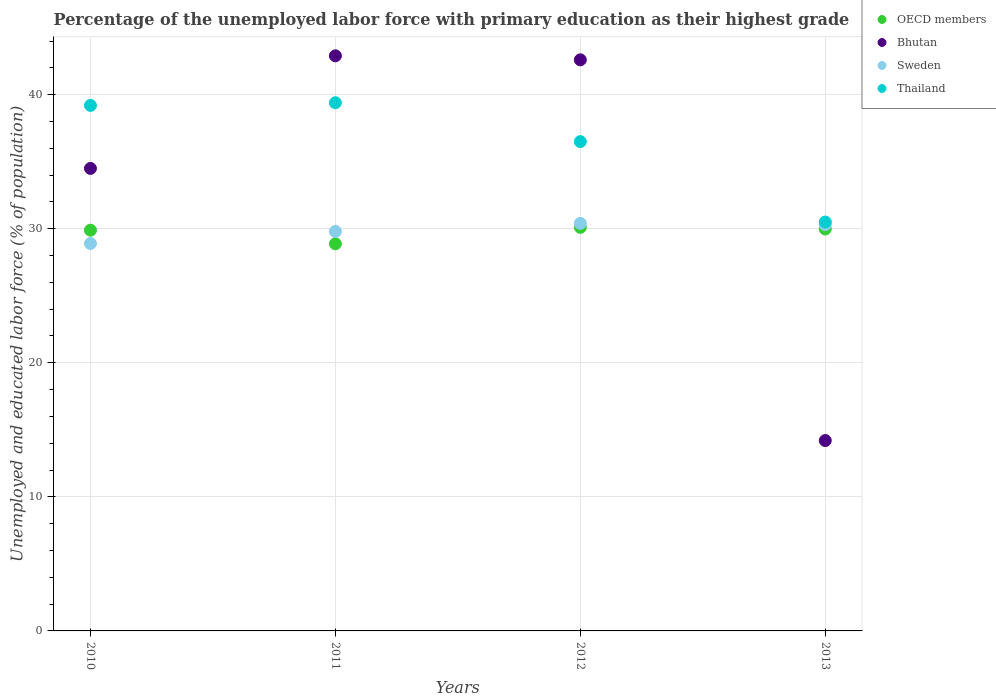How many different coloured dotlines are there?
Keep it short and to the point. 4. What is the percentage of the unemployed labor force with primary education in Bhutan in 2012?
Provide a succinct answer. 42.6. Across all years, what is the maximum percentage of the unemployed labor force with primary education in Bhutan?
Offer a terse response. 42.9. Across all years, what is the minimum percentage of the unemployed labor force with primary education in OECD members?
Offer a very short reply. 28.88. In which year was the percentage of the unemployed labor force with primary education in Bhutan maximum?
Make the answer very short. 2011. In which year was the percentage of the unemployed labor force with primary education in Thailand minimum?
Offer a very short reply. 2013. What is the total percentage of the unemployed labor force with primary education in OECD members in the graph?
Keep it short and to the point. 118.86. What is the difference between the percentage of the unemployed labor force with primary education in Thailand in 2011 and that in 2012?
Provide a succinct answer. 2.9. What is the difference between the percentage of the unemployed labor force with primary education in Thailand in 2011 and the percentage of the unemployed labor force with primary education in Bhutan in 2013?
Your response must be concise. 25.2. What is the average percentage of the unemployed labor force with primary education in Thailand per year?
Your answer should be compact. 36.4. In the year 2010, what is the difference between the percentage of the unemployed labor force with primary education in Thailand and percentage of the unemployed labor force with primary education in Sweden?
Give a very brief answer. 10.3. In how many years, is the percentage of the unemployed labor force with primary education in Thailand greater than 12 %?
Offer a terse response. 4. What is the ratio of the percentage of the unemployed labor force with primary education in OECD members in 2010 to that in 2012?
Your answer should be very brief. 0.99. Is the percentage of the unemployed labor force with primary education in Sweden in 2011 less than that in 2012?
Give a very brief answer. Yes. What is the difference between the highest and the second highest percentage of the unemployed labor force with primary education in OECD members?
Your response must be concise. 0.12. What is the difference between the highest and the lowest percentage of the unemployed labor force with primary education in Sweden?
Give a very brief answer. 1.5. Is the sum of the percentage of the unemployed labor force with primary education in Thailand in 2011 and 2013 greater than the maximum percentage of the unemployed labor force with primary education in OECD members across all years?
Your response must be concise. Yes. Is it the case that in every year, the sum of the percentage of the unemployed labor force with primary education in OECD members and percentage of the unemployed labor force with primary education in Bhutan  is greater than the sum of percentage of the unemployed labor force with primary education in Sweden and percentage of the unemployed labor force with primary education in Thailand?
Your answer should be compact. No. Is it the case that in every year, the sum of the percentage of the unemployed labor force with primary education in OECD members and percentage of the unemployed labor force with primary education in Thailand  is greater than the percentage of the unemployed labor force with primary education in Sweden?
Offer a very short reply. Yes. Is the percentage of the unemployed labor force with primary education in OECD members strictly greater than the percentage of the unemployed labor force with primary education in Bhutan over the years?
Give a very brief answer. No. How many dotlines are there?
Provide a short and direct response. 4. How many years are there in the graph?
Your answer should be compact. 4. What is the difference between two consecutive major ticks on the Y-axis?
Provide a short and direct response. 10. Does the graph contain grids?
Make the answer very short. Yes. Where does the legend appear in the graph?
Offer a terse response. Top right. How are the legend labels stacked?
Make the answer very short. Vertical. What is the title of the graph?
Keep it short and to the point. Percentage of the unemployed labor force with primary education as their highest grade. What is the label or title of the X-axis?
Provide a succinct answer. Years. What is the label or title of the Y-axis?
Offer a terse response. Unemployed and educated labor force (% of population). What is the Unemployed and educated labor force (% of population) of OECD members in 2010?
Provide a succinct answer. 29.89. What is the Unemployed and educated labor force (% of population) of Bhutan in 2010?
Offer a terse response. 34.5. What is the Unemployed and educated labor force (% of population) in Sweden in 2010?
Your answer should be compact. 28.9. What is the Unemployed and educated labor force (% of population) of Thailand in 2010?
Offer a very short reply. 39.2. What is the Unemployed and educated labor force (% of population) of OECD members in 2011?
Your answer should be very brief. 28.88. What is the Unemployed and educated labor force (% of population) in Bhutan in 2011?
Your answer should be very brief. 42.9. What is the Unemployed and educated labor force (% of population) in Sweden in 2011?
Ensure brevity in your answer.  29.8. What is the Unemployed and educated labor force (% of population) of Thailand in 2011?
Provide a short and direct response. 39.4. What is the Unemployed and educated labor force (% of population) in OECD members in 2012?
Your answer should be very brief. 30.1. What is the Unemployed and educated labor force (% of population) in Bhutan in 2012?
Your response must be concise. 42.6. What is the Unemployed and educated labor force (% of population) of Sweden in 2012?
Provide a succinct answer. 30.4. What is the Unemployed and educated labor force (% of population) of Thailand in 2012?
Offer a very short reply. 36.5. What is the Unemployed and educated labor force (% of population) in OECD members in 2013?
Provide a short and direct response. 29.98. What is the Unemployed and educated labor force (% of population) in Bhutan in 2013?
Provide a succinct answer. 14.2. What is the Unemployed and educated labor force (% of population) in Sweden in 2013?
Your response must be concise. 30.3. What is the Unemployed and educated labor force (% of population) in Thailand in 2013?
Make the answer very short. 30.5. Across all years, what is the maximum Unemployed and educated labor force (% of population) of OECD members?
Keep it short and to the point. 30.1. Across all years, what is the maximum Unemployed and educated labor force (% of population) in Bhutan?
Give a very brief answer. 42.9. Across all years, what is the maximum Unemployed and educated labor force (% of population) of Sweden?
Give a very brief answer. 30.4. Across all years, what is the maximum Unemployed and educated labor force (% of population) in Thailand?
Your response must be concise. 39.4. Across all years, what is the minimum Unemployed and educated labor force (% of population) in OECD members?
Your answer should be compact. 28.88. Across all years, what is the minimum Unemployed and educated labor force (% of population) in Bhutan?
Provide a succinct answer. 14.2. Across all years, what is the minimum Unemployed and educated labor force (% of population) in Sweden?
Provide a short and direct response. 28.9. Across all years, what is the minimum Unemployed and educated labor force (% of population) of Thailand?
Your answer should be very brief. 30.5. What is the total Unemployed and educated labor force (% of population) of OECD members in the graph?
Your response must be concise. 118.86. What is the total Unemployed and educated labor force (% of population) of Bhutan in the graph?
Provide a succinct answer. 134.2. What is the total Unemployed and educated labor force (% of population) of Sweden in the graph?
Offer a very short reply. 119.4. What is the total Unemployed and educated labor force (% of population) in Thailand in the graph?
Offer a very short reply. 145.6. What is the difference between the Unemployed and educated labor force (% of population) in OECD members in 2010 and that in 2011?
Offer a very short reply. 1.01. What is the difference between the Unemployed and educated labor force (% of population) in Sweden in 2010 and that in 2011?
Provide a short and direct response. -0.9. What is the difference between the Unemployed and educated labor force (% of population) in OECD members in 2010 and that in 2012?
Give a very brief answer. -0.21. What is the difference between the Unemployed and educated labor force (% of population) of Bhutan in 2010 and that in 2012?
Your response must be concise. -8.1. What is the difference between the Unemployed and educated labor force (% of population) of Thailand in 2010 and that in 2012?
Offer a terse response. 2.7. What is the difference between the Unemployed and educated labor force (% of population) in OECD members in 2010 and that in 2013?
Keep it short and to the point. -0.09. What is the difference between the Unemployed and educated labor force (% of population) of Bhutan in 2010 and that in 2013?
Your answer should be very brief. 20.3. What is the difference between the Unemployed and educated labor force (% of population) of Thailand in 2010 and that in 2013?
Provide a succinct answer. 8.7. What is the difference between the Unemployed and educated labor force (% of population) of OECD members in 2011 and that in 2012?
Your answer should be compact. -1.23. What is the difference between the Unemployed and educated labor force (% of population) of Sweden in 2011 and that in 2012?
Ensure brevity in your answer.  -0.6. What is the difference between the Unemployed and educated labor force (% of population) of OECD members in 2011 and that in 2013?
Ensure brevity in your answer.  -1.11. What is the difference between the Unemployed and educated labor force (% of population) of Bhutan in 2011 and that in 2013?
Keep it short and to the point. 28.7. What is the difference between the Unemployed and educated labor force (% of population) of Sweden in 2011 and that in 2013?
Make the answer very short. -0.5. What is the difference between the Unemployed and educated labor force (% of population) of Thailand in 2011 and that in 2013?
Make the answer very short. 8.9. What is the difference between the Unemployed and educated labor force (% of population) of OECD members in 2012 and that in 2013?
Your answer should be very brief. 0.12. What is the difference between the Unemployed and educated labor force (% of population) in Bhutan in 2012 and that in 2013?
Your answer should be very brief. 28.4. What is the difference between the Unemployed and educated labor force (% of population) of OECD members in 2010 and the Unemployed and educated labor force (% of population) of Bhutan in 2011?
Keep it short and to the point. -13.01. What is the difference between the Unemployed and educated labor force (% of population) in OECD members in 2010 and the Unemployed and educated labor force (% of population) in Sweden in 2011?
Offer a terse response. 0.09. What is the difference between the Unemployed and educated labor force (% of population) of OECD members in 2010 and the Unemployed and educated labor force (% of population) of Thailand in 2011?
Give a very brief answer. -9.51. What is the difference between the Unemployed and educated labor force (% of population) of OECD members in 2010 and the Unemployed and educated labor force (% of population) of Bhutan in 2012?
Your response must be concise. -12.71. What is the difference between the Unemployed and educated labor force (% of population) in OECD members in 2010 and the Unemployed and educated labor force (% of population) in Sweden in 2012?
Make the answer very short. -0.51. What is the difference between the Unemployed and educated labor force (% of population) of OECD members in 2010 and the Unemployed and educated labor force (% of population) of Thailand in 2012?
Ensure brevity in your answer.  -6.61. What is the difference between the Unemployed and educated labor force (% of population) of Bhutan in 2010 and the Unemployed and educated labor force (% of population) of Thailand in 2012?
Give a very brief answer. -2. What is the difference between the Unemployed and educated labor force (% of population) in Sweden in 2010 and the Unemployed and educated labor force (% of population) in Thailand in 2012?
Provide a short and direct response. -7.6. What is the difference between the Unemployed and educated labor force (% of population) in OECD members in 2010 and the Unemployed and educated labor force (% of population) in Bhutan in 2013?
Ensure brevity in your answer.  15.69. What is the difference between the Unemployed and educated labor force (% of population) in OECD members in 2010 and the Unemployed and educated labor force (% of population) in Sweden in 2013?
Offer a terse response. -0.41. What is the difference between the Unemployed and educated labor force (% of population) of OECD members in 2010 and the Unemployed and educated labor force (% of population) of Thailand in 2013?
Provide a succinct answer. -0.61. What is the difference between the Unemployed and educated labor force (% of population) in Bhutan in 2010 and the Unemployed and educated labor force (% of population) in Sweden in 2013?
Offer a terse response. 4.2. What is the difference between the Unemployed and educated labor force (% of population) in Sweden in 2010 and the Unemployed and educated labor force (% of population) in Thailand in 2013?
Ensure brevity in your answer.  -1.6. What is the difference between the Unemployed and educated labor force (% of population) in OECD members in 2011 and the Unemployed and educated labor force (% of population) in Bhutan in 2012?
Provide a succinct answer. -13.72. What is the difference between the Unemployed and educated labor force (% of population) of OECD members in 2011 and the Unemployed and educated labor force (% of population) of Sweden in 2012?
Keep it short and to the point. -1.52. What is the difference between the Unemployed and educated labor force (% of population) in OECD members in 2011 and the Unemployed and educated labor force (% of population) in Thailand in 2012?
Your answer should be compact. -7.62. What is the difference between the Unemployed and educated labor force (% of population) of Sweden in 2011 and the Unemployed and educated labor force (% of population) of Thailand in 2012?
Provide a short and direct response. -6.7. What is the difference between the Unemployed and educated labor force (% of population) of OECD members in 2011 and the Unemployed and educated labor force (% of population) of Bhutan in 2013?
Provide a short and direct response. 14.68. What is the difference between the Unemployed and educated labor force (% of population) of OECD members in 2011 and the Unemployed and educated labor force (% of population) of Sweden in 2013?
Provide a short and direct response. -1.42. What is the difference between the Unemployed and educated labor force (% of population) of OECD members in 2011 and the Unemployed and educated labor force (% of population) of Thailand in 2013?
Give a very brief answer. -1.62. What is the difference between the Unemployed and educated labor force (% of population) in Bhutan in 2011 and the Unemployed and educated labor force (% of population) in Thailand in 2013?
Keep it short and to the point. 12.4. What is the difference between the Unemployed and educated labor force (% of population) in Sweden in 2011 and the Unemployed and educated labor force (% of population) in Thailand in 2013?
Make the answer very short. -0.7. What is the difference between the Unemployed and educated labor force (% of population) of OECD members in 2012 and the Unemployed and educated labor force (% of population) of Bhutan in 2013?
Make the answer very short. 15.9. What is the difference between the Unemployed and educated labor force (% of population) in OECD members in 2012 and the Unemployed and educated labor force (% of population) in Sweden in 2013?
Ensure brevity in your answer.  -0.2. What is the difference between the Unemployed and educated labor force (% of population) of OECD members in 2012 and the Unemployed and educated labor force (% of population) of Thailand in 2013?
Your answer should be very brief. -0.4. What is the average Unemployed and educated labor force (% of population) in OECD members per year?
Keep it short and to the point. 29.71. What is the average Unemployed and educated labor force (% of population) in Bhutan per year?
Your answer should be very brief. 33.55. What is the average Unemployed and educated labor force (% of population) of Sweden per year?
Provide a succinct answer. 29.85. What is the average Unemployed and educated labor force (% of population) of Thailand per year?
Ensure brevity in your answer.  36.4. In the year 2010, what is the difference between the Unemployed and educated labor force (% of population) of OECD members and Unemployed and educated labor force (% of population) of Bhutan?
Give a very brief answer. -4.61. In the year 2010, what is the difference between the Unemployed and educated labor force (% of population) of OECD members and Unemployed and educated labor force (% of population) of Sweden?
Your answer should be very brief. 0.99. In the year 2010, what is the difference between the Unemployed and educated labor force (% of population) of OECD members and Unemployed and educated labor force (% of population) of Thailand?
Your answer should be very brief. -9.31. In the year 2011, what is the difference between the Unemployed and educated labor force (% of population) of OECD members and Unemployed and educated labor force (% of population) of Bhutan?
Offer a very short reply. -14.02. In the year 2011, what is the difference between the Unemployed and educated labor force (% of population) of OECD members and Unemployed and educated labor force (% of population) of Sweden?
Provide a succinct answer. -0.92. In the year 2011, what is the difference between the Unemployed and educated labor force (% of population) of OECD members and Unemployed and educated labor force (% of population) of Thailand?
Make the answer very short. -10.52. In the year 2011, what is the difference between the Unemployed and educated labor force (% of population) in Bhutan and Unemployed and educated labor force (% of population) in Sweden?
Provide a short and direct response. 13.1. In the year 2012, what is the difference between the Unemployed and educated labor force (% of population) in OECD members and Unemployed and educated labor force (% of population) in Bhutan?
Ensure brevity in your answer.  -12.5. In the year 2012, what is the difference between the Unemployed and educated labor force (% of population) in OECD members and Unemployed and educated labor force (% of population) in Sweden?
Offer a very short reply. -0.3. In the year 2012, what is the difference between the Unemployed and educated labor force (% of population) in OECD members and Unemployed and educated labor force (% of population) in Thailand?
Ensure brevity in your answer.  -6.4. In the year 2012, what is the difference between the Unemployed and educated labor force (% of population) of Bhutan and Unemployed and educated labor force (% of population) of Sweden?
Ensure brevity in your answer.  12.2. In the year 2013, what is the difference between the Unemployed and educated labor force (% of population) in OECD members and Unemployed and educated labor force (% of population) in Bhutan?
Your response must be concise. 15.78. In the year 2013, what is the difference between the Unemployed and educated labor force (% of population) of OECD members and Unemployed and educated labor force (% of population) of Sweden?
Provide a short and direct response. -0.32. In the year 2013, what is the difference between the Unemployed and educated labor force (% of population) in OECD members and Unemployed and educated labor force (% of population) in Thailand?
Your answer should be very brief. -0.52. In the year 2013, what is the difference between the Unemployed and educated labor force (% of population) of Bhutan and Unemployed and educated labor force (% of population) of Sweden?
Offer a very short reply. -16.1. In the year 2013, what is the difference between the Unemployed and educated labor force (% of population) in Bhutan and Unemployed and educated labor force (% of population) in Thailand?
Make the answer very short. -16.3. What is the ratio of the Unemployed and educated labor force (% of population) in OECD members in 2010 to that in 2011?
Your answer should be compact. 1.04. What is the ratio of the Unemployed and educated labor force (% of population) in Bhutan in 2010 to that in 2011?
Your response must be concise. 0.8. What is the ratio of the Unemployed and educated labor force (% of population) in Sweden in 2010 to that in 2011?
Make the answer very short. 0.97. What is the ratio of the Unemployed and educated labor force (% of population) of Thailand in 2010 to that in 2011?
Ensure brevity in your answer.  0.99. What is the ratio of the Unemployed and educated labor force (% of population) of OECD members in 2010 to that in 2012?
Offer a terse response. 0.99. What is the ratio of the Unemployed and educated labor force (% of population) of Bhutan in 2010 to that in 2012?
Offer a very short reply. 0.81. What is the ratio of the Unemployed and educated labor force (% of population) of Sweden in 2010 to that in 2012?
Your response must be concise. 0.95. What is the ratio of the Unemployed and educated labor force (% of population) in Thailand in 2010 to that in 2012?
Make the answer very short. 1.07. What is the ratio of the Unemployed and educated labor force (% of population) of OECD members in 2010 to that in 2013?
Your answer should be very brief. 1. What is the ratio of the Unemployed and educated labor force (% of population) in Bhutan in 2010 to that in 2013?
Make the answer very short. 2.43. What is the ratio of the Unemployed and educated labor force (% of population) of Sweden in 2010 to that in 2013?
Ensure brevity in your answer.  0.95. What is the ratio of the Unemployed and educated labor force (% of population) of Thailand in 2010 to that in 2013?
Your answer should be very brief. 1.29. What is the ratio of the Unemployed and educated labor force (% of population) in OECD members in 2011 to that in 2012?
Offer a terse response. 0.96. What is the ratio of the Unemployed and educated labor force (% of population) in Sweden in 2011 to that in 2012?
Offer a very short reply. 0.98. What is the ratio of the Unemployed and educated labor force (% of population) in Thailand in 2011 to that in 2012?
Keep it short and to the point. 1.08. What is the ratio of the Unemployed and educated labor force (% of population) in OECD members in 2011 to that in 2013?
Provide a short and direct response. 0.96. What is the ratio of the Unemployed and educated labor force (% of population) in Bhutan in 2011 to that in 2013?
Your answer should be very brief. 3.02. What is the ratio of the Unemployed and educated labor force (% of population) of Sweden in 2011 to that in 2013?
Give a very brief answer. 0.98. What is the ratio of the Unemployed and educated labor force (% of population) in Thailand in 2011 to that in 2013?
Make the answer very short. 1.29. What is the ratio of the Unemployed and educated labor force (% of population) of OECD members in 2012 to that in 2013?
Provide a short and direct response. 1. What is the ratio of the Unemployed and educated labor force (% of population) in Thailand in 2012 to that in 2013?
Give a very brief answer. 1.2. What is the difference between the highest and the second highest Unemployed and educated labor force (% of population) of OECD members?
Offer a very short reply. 0.12. What is the difference between the highest and the second highest Unemployed and educated labor force (% of population) of Bhutan?
Make the answer very short. 0.3. What is the difference between the highest and the lowest Unemployed and educated labor force (% of population) in OECD members?
Give a very brief answer. 1.23. What is the difference between the highest and the lowest Unemployed and educated labor force (% of population) in Bhutan?
Provide a short and direct response. 28.7. What is the difference between the highest and the lowest Unemployed and educated labor force (% of population) of Thailand?
Your answer should be very brief. 8.9. 